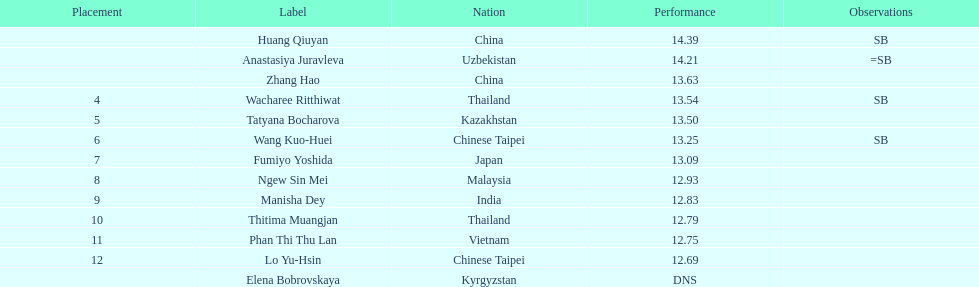How many contestants were from thailand? 2. 